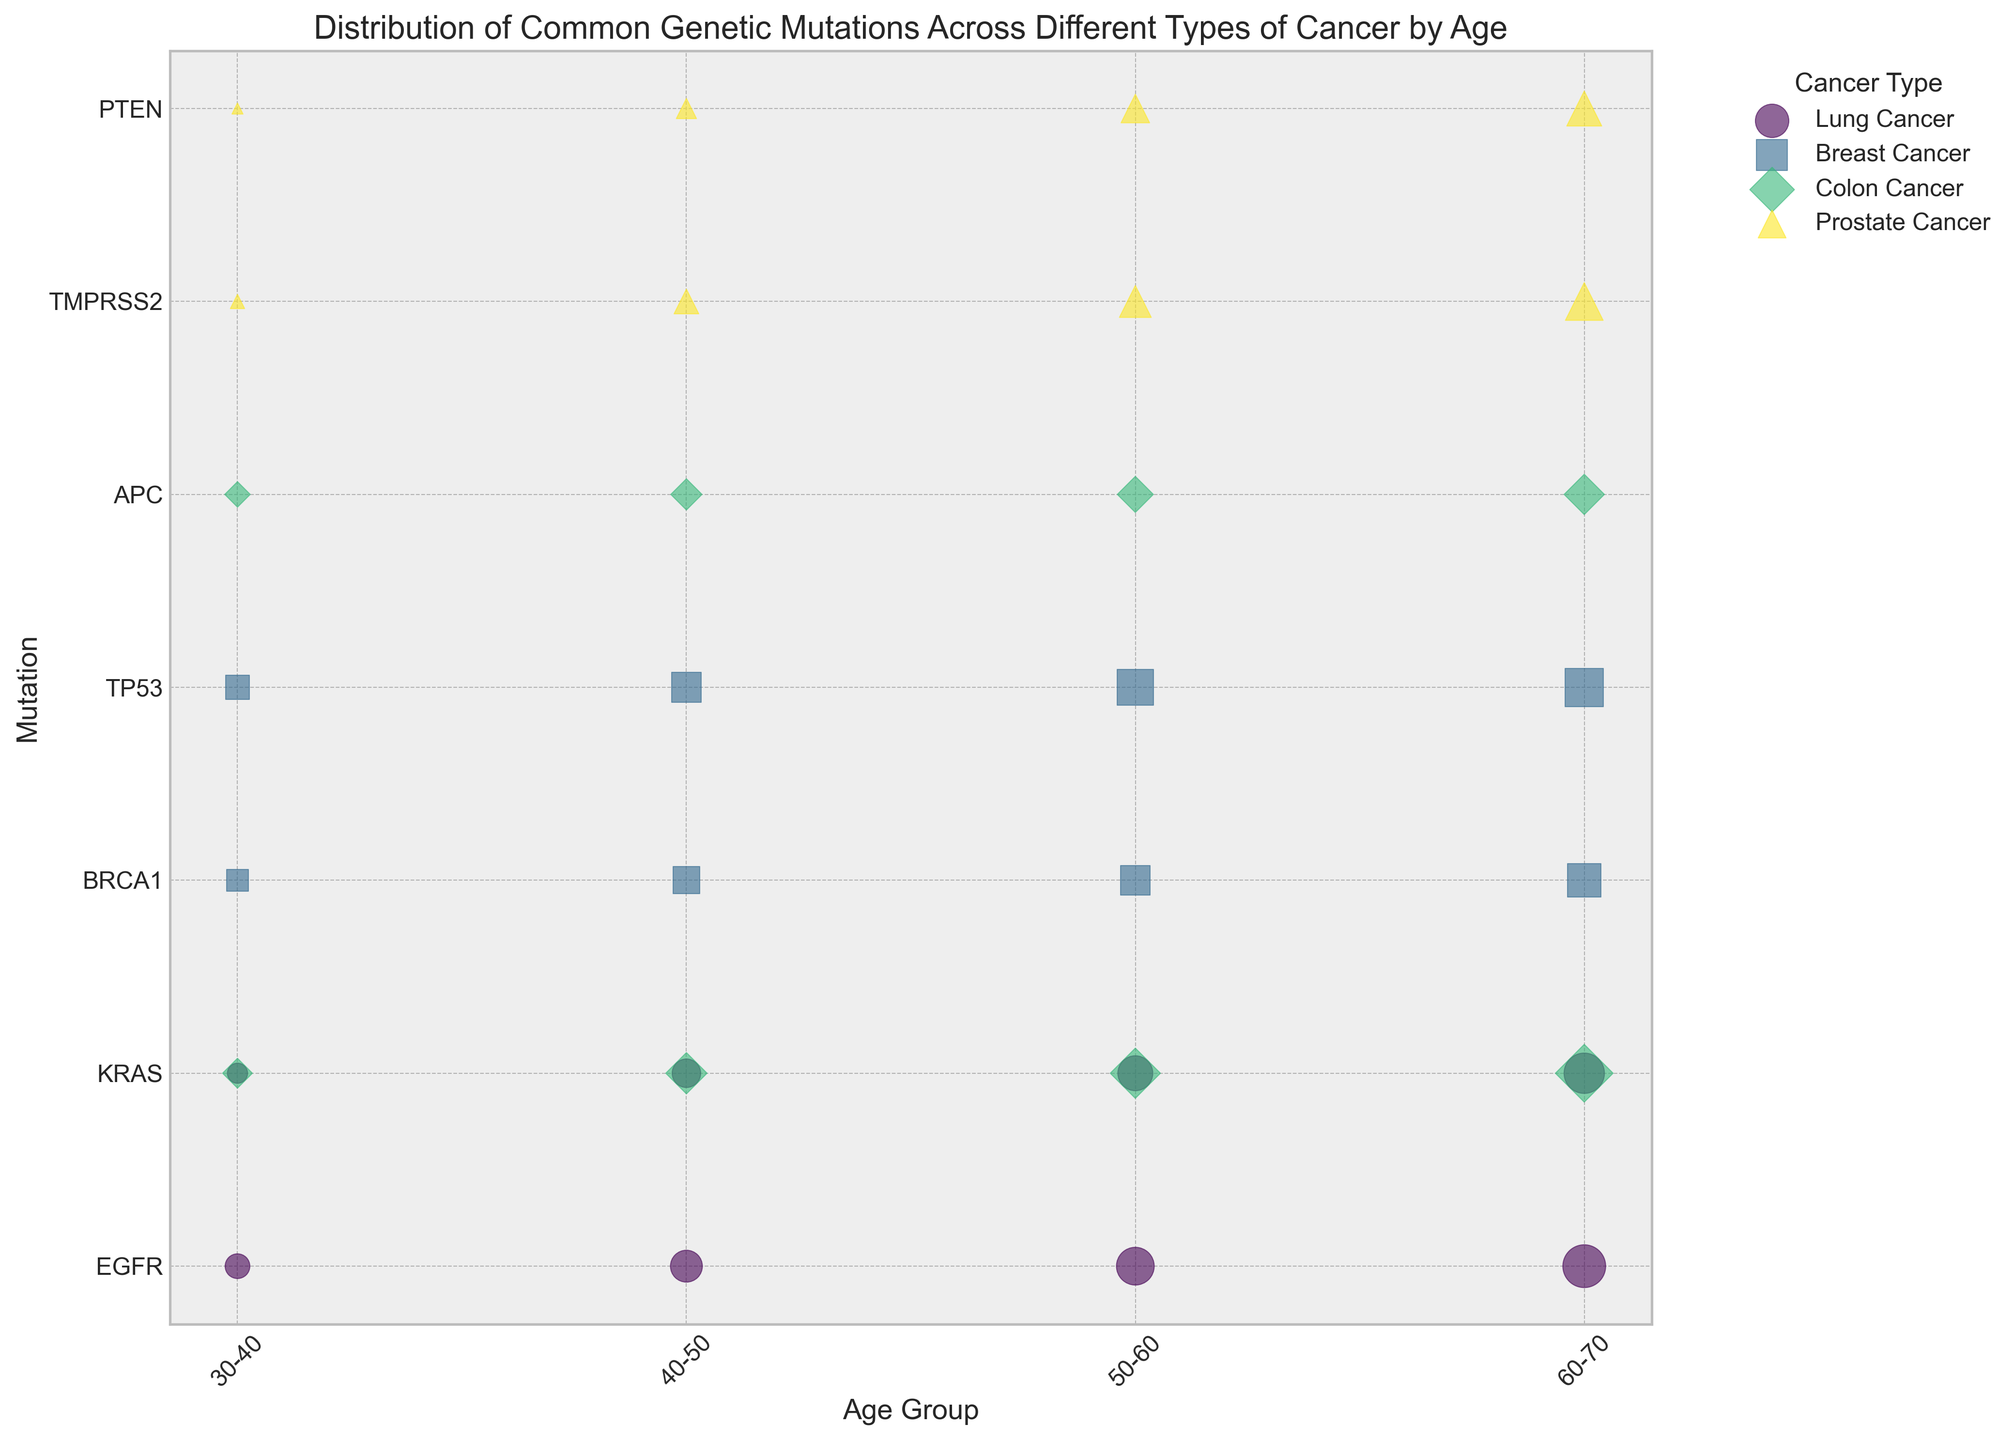What type of cancer has the highest frequency of a genetic mutation in the 60-70 age group? Look for the largest-sized bubble within the 60-70 age group and identify its cancer type. Here, Lung Cancer with EGFR has the largest bubble, indicating the highest frequency.
Answer: Lung Cancer Which genetic mutation in Colon Cancer has a higher frequency in the 50-60 age group? APC or KRAS? Compare the bubble sizes for the two mutations within that age group. The KRAS mutation has a larger bubble, indicating a higher frequency.
Answer: KRAS Which cancer type shows the most variation in mutation frequencies across different age groups? Observe the cancer types and compare the variance in bubble sizes across age groups. Lung Cancer shows considerable changes in its bubble sizes across age groups, indicating the most variation.
Answer: Lung Cancer What is the combined frequency of the KRAS mutation in both Lung Cancer and Colon Cancer for the 60-70 age group? Sum the sizes of the KRAS mutation bubbles for both Lung Cancer and Colon Cancer in the 60-70 age group. Lung Cancer (40) + Colon Cancer (41) = 81
Answer: 81 Between the BRCA1 and TP53 mutations in Breast Cancer, which is more frequent in the 40-50 age group? Compare the sizes of the bubbles for BRCA1 and TP53 within the 40-50 age group. The TP53 mutation has a larger bubble, indicating a higher frequency.
Answer: TP53 Is the frequency of the TMPRSS2 mutation in Prostate Cancer higher or lower than the EGFR mutation in Lung Cancer for the 50-60 age group? Compare the bubble sizes for TMPRSS2 in Prostate Cancer and EGFR in Lung Cancer for the 50-60 age group. The EGFR mutation has a larger bubble, indicating a higher frequency.
Answer: Lower What trend can be observed for the frequency of the PTEN mutation in Prostate Cancer as age increases? Follow the sizes of the PTEN mutation bubbles in Prostate Cancer across age groups. The bubble sizes increase with age, indicating a rising trend.
Answer: Increasing In the 30-40 age group, which has a higher frequency: EGFR in Lung Cancer or BRCA1 in Breast Cancer? Compare the bubble sizes for EGFR in Lung Cancer and BRCA1 in Breast Cancer for the 30-40 age group. The EGFR mutation has a larger bubble, indicating a higher frequency.
Answer: EGFR How does the frequency of APC in Colon Cancer for the 40-50 age group compare to TMPRSS2 in Prostate Cancer for the same age group? Compare the bubble sizes for APC in Colon Cancer and TMPRSS2 in Prostate Cancer for the 40-50 age group. The bubble for TMPRSS2 in Prostate Cancer is larger, indicating a higher frequency.
Answer: Lower 